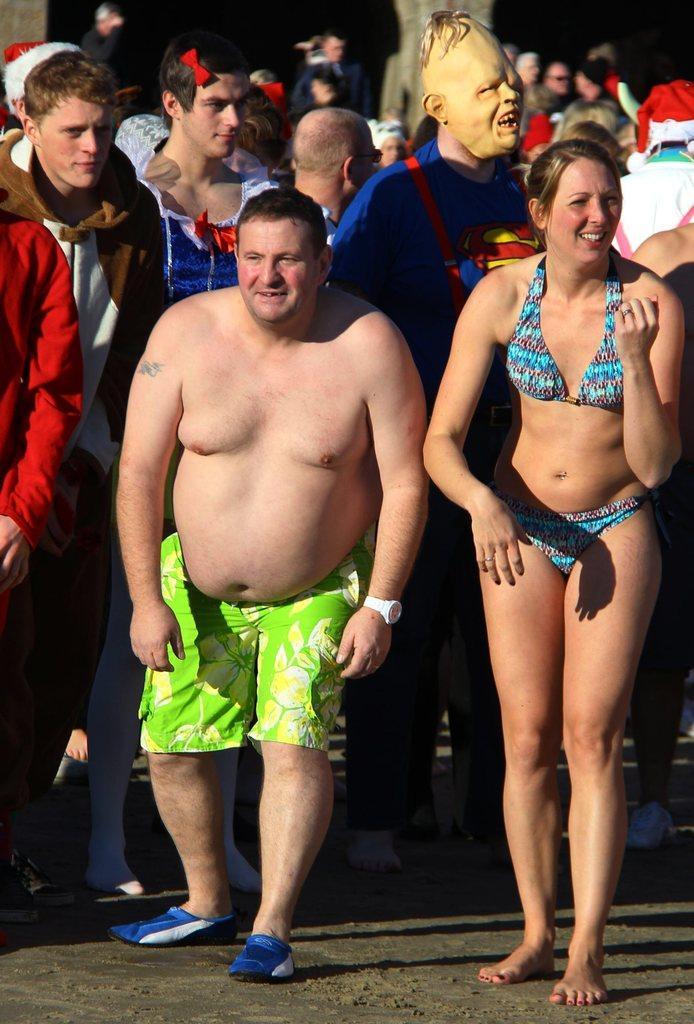In one or two sentences, can you explain what this image depicts? In this image we can see people standing on the ground. 